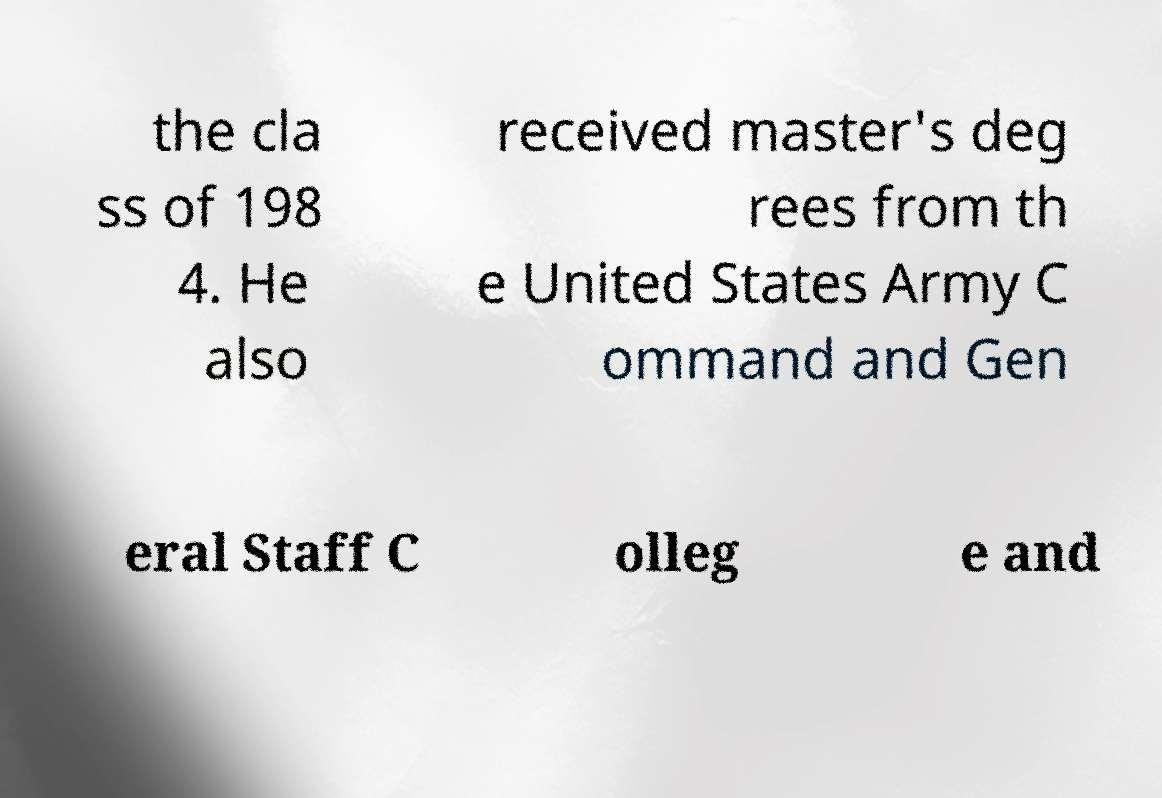Can you accurately transcribe the text from the provided image for me? the cla ss of 198 4. He also received master's deg rees from th e United States Army C ommand and Gen eral Staff C olleg e and 